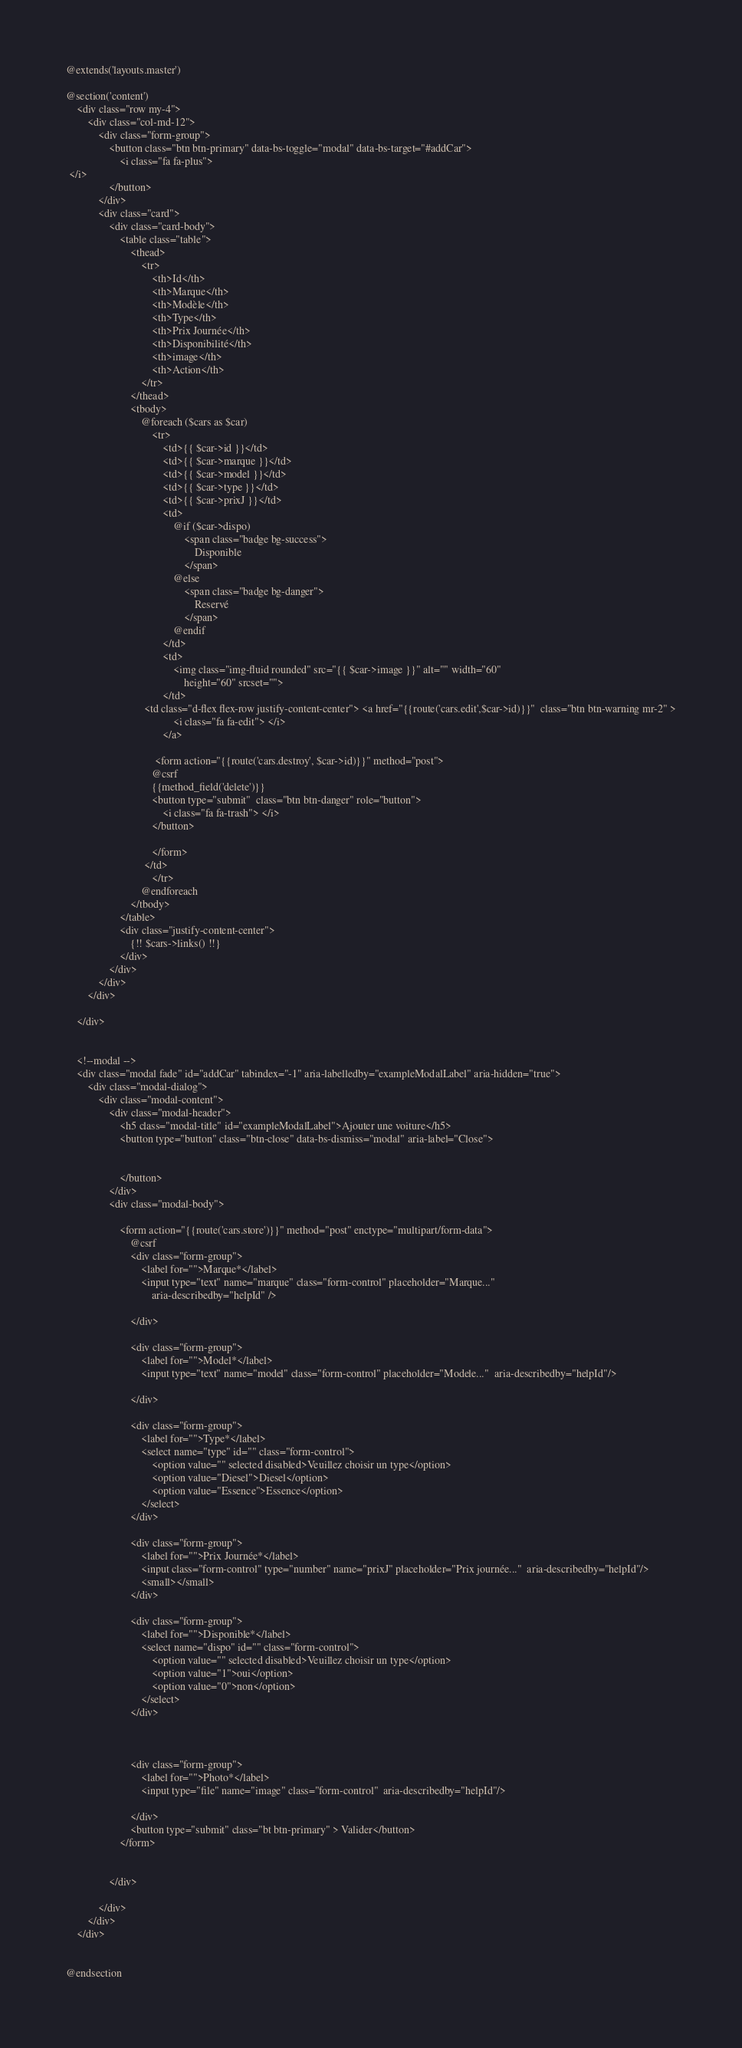<code> <loc_0><loc_0><loc_500><loc_500><_PHP_>@extends('layouts.master')

@section('content')
    <div class="row my-4">
        <div class="col-md-12">
            <div class="form-group">
                <button class="btn btn-primary" data-bs-toggle="modal" data-bs-target="#addCar">
                    <i class="fa fa-plus">
 </i>
                </button>
            </div>
            <div class="card">
                <div class="card-body">
                    <table class="table">
                        <thead>
                            <tr>
                                <th>Id</th>
                                <th>Marque</th>
                                <th>Modèle</th>
                                <th>Type</th>
                                <th>Prix Journée</th>
                                <th>Disponibilité</th>
                                <th>image</th>
                                <th>Action</th>
                            </tr>
                        </thead>
                        <tbody>
                            @foreach ($cars as $car)
                                <tr>
                                    <td>{{ $car->id }}</td>
                                    <td>{{ $car->marque }}</td>
                                    <td>{{ $car->model }}</td>
                                    <td>{{ $car->type }}</td>
                                    <td>{{ $car->prixJ }}</td>
                                    <td>
                                        @if ($car->dispo)
                                            <span class="badge bg-success">
                                                Disponible
                                            </span>
                                        @else
                                            <span class="badge bg-danger">
                                                Reservé
                                            </span>
                                        @endif
                                    </td>
                                    <td>
                                        <img class="img-fluid rounded" src="{{ $car->image }}" alt="" width="60"
                                            height="60" srcset="">
                                    </td>
                             <td class="d-flex flex-row justify-content-center"> <a href="{{route('cars.edit',$car->id)}}"  class="btn btn-warning mr-2" >
                                        <i class="fa fa-edit"> </i>
                                    </a>

                                 <form action="{{route('cars.destroy', $car->id)}}" method="post">
                                @csrf
                                {{method_field('delete')}}
                                <button type="submit"  class="btn btn-danger" role="button">
                                    <i class="fa fa-trash"> </i>
                                </button>

                                </form>
                             </td>
                                </tr>
                            @endforeach
                        </tbody>
                    </table>
                    <div class="justify-content-center">
                        {!! $cars->links() !!}
                    </div>
                </div>
            </div>
        </div>

    </div>


    <!--modal -->
    <div class="modal fade" id="addCar" tabindex="-1" aria-labelledby="exampleModalLabel" aria-hidden="true">
        <div class="modal-dialog">
            <div class="modal-content">
                <div class="modal-header">
                    <h5 class="modal-title" id="exampleModalLabel">Ajouter une voiture</h5>
                    <button type="button" class="btn-close" data-bs-dismiss="modal" aria-label="Close">


                    </button>
                </div>
                <div class="modal-body">

                    <form action="{{route('cars.store')}}" method="post" enctype="multipart/form-data">
                        @csrf
                        <div class="form-group">
                            <label for="">Marque*</label>
                            <input type="text" name="marque" class="form-control" placeholder="Marque..."
                                aria-describedby="helpId" />

                        </div>

                        <div class="form-group">
                            <label for="">Model*</label>
                            <input type="text" name="model" class="form-control" placeholder="Modele..."  aria-describedby="helpId"/>

                        </div>

                        <div class="form-group">
                            <label for="">Type*</label>
                            <select name="type" id="" class="form-control">
                                <option value="" selected disabled>Veuillez choisir un type</option>
                                <option value="Diesel">Diesel</option>
                                <option value="Essence">Essence</option>
                            </select>
                        </div>

                        <div class="form-group">
                            <label for="">Prix Journée*</label>
                            <input class="form-control" type="number" name="prixJ" placeholder="Prix journée..."  aria-describedby="helpId"/>
                            <small></small>
                        </div>

                        <div class="form-group">
                            <label for="">Disponible*</label>
                            <select name="dispo" id="" class="form-control">
                                <option value="" selected disabled>Veuillez choisir un type</option>
                                <option value="1">oui</option>
                                <option value="0">non</option>
                            </select>
                        </div>



                        <div class="form-group">
                            <label for="">Photo*</label>
                            <input type="file" name="image" class="form-control"  aria-describedby="helpId"/>

                        </div>
                        <button type="submit" class="bt btn-primary" > Valider</button>
                    </form>


                </div>

            </div>
        </div>
    </div>


@endsection
</code> 